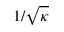Convert formula to latex. <formula><loc_0><loc_0><loc_500><loc_500>1 / { \sqrt { \kappa } }</formula> 